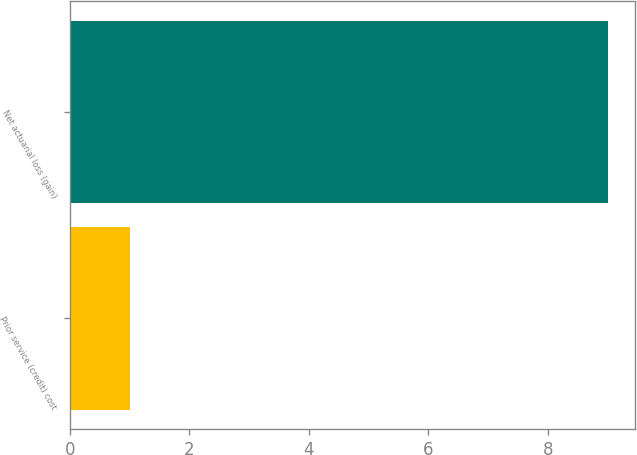Convert chart. <chart><loc_0><loc_0><loc_500><loc_500><bar_chart><fcel>Prior service (credit) cost<fcel>Net actuarial loss (gain)<nl><fcel>1<fcel>9<nl></chart> 